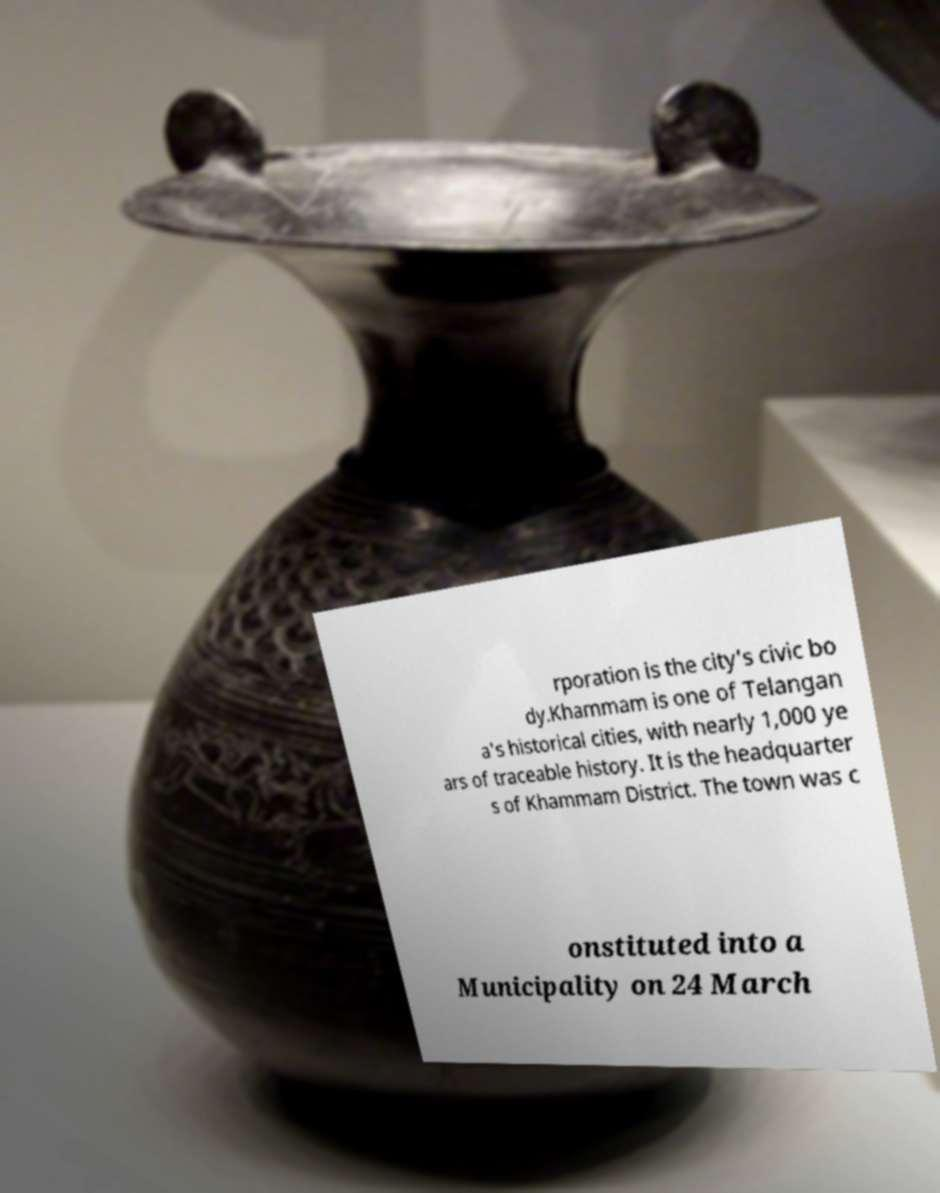I need the written content from this picture converted into text. Can you do that? rporation is the city's civic bo dy.Khammam is one of Telangan a's historical cities, with nearly 1,000 ye ars of traceable history. It is the headquarter s of Khammam District. The town was c onstituted into a Municipality on 24 March 